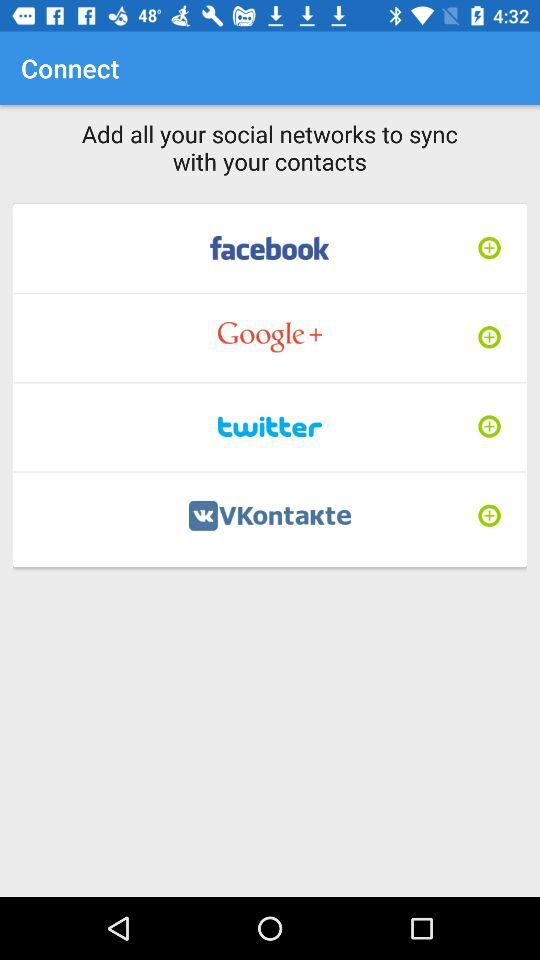How many social networks are there in total?
Answer the question using a single word or phrase. 4 